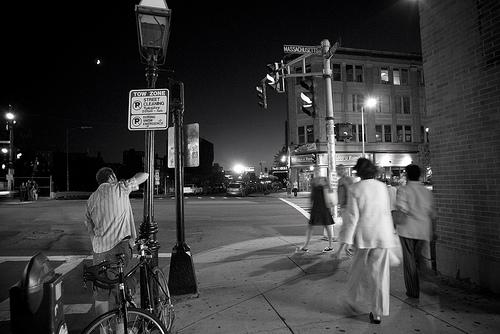Question: what time of day is it?
Choices:
A. Evening.
B. Noon.
C. Night.
D. Morning.
Answer with the letter. Answer: C Question: what kind of photo is this?
Choices:
A. Polaroid.
B. Explicit.
C. Photoshop.
D. Black and white.
Answer with the letter. Answer: D Question: what is the building on the right made of?
Choices:
A. Wood.
B. Concrete.
C. Bricks.
D. Glass.
Answer with the letter. Answer: C 